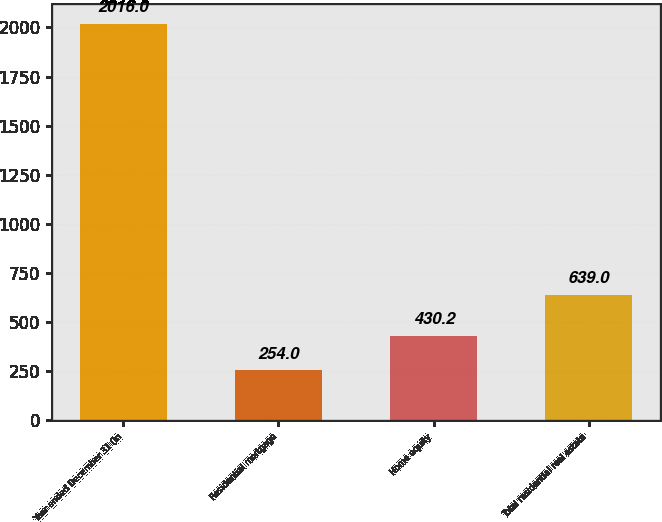Convert chart. <chart><loc_0><loc_0><loc_500><loc_500><bar_chart><fcel>Year ended December 31 (in<fcel>Residential mortgage<fcel>Home equity<fcel>Total residential real estate<nl><fcel>2016<fcel>254<fcel>430.2<fcel>639<nl></chart> 